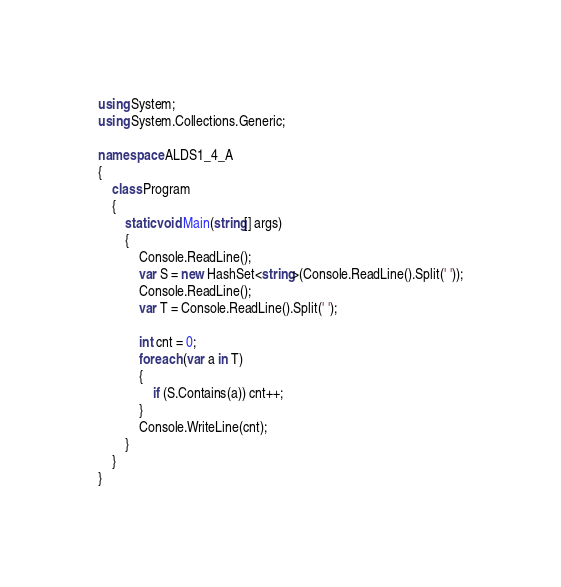Convert code to text. <code><loc_0><loc_0><loc_500><loc_500><_C#_>using System;
using System.Collections.Generic;

namespace ALDS1_4_A
{
    class Program
    {
        static void Main(string[] args)
        {
            Console.ReadLine();
            var S = new HashSet<string>(Console.ReadLine().Split(' '));
            Console.ReadLine();
            var T = Console.ReadLine().Split(' ');

            int cnt = 0;
            foreach (var a in T)
            {
                if (S.Contains(a)) cnt++;
            }
            Console.WriteLine(cnt);
        }
    }
}</code> 